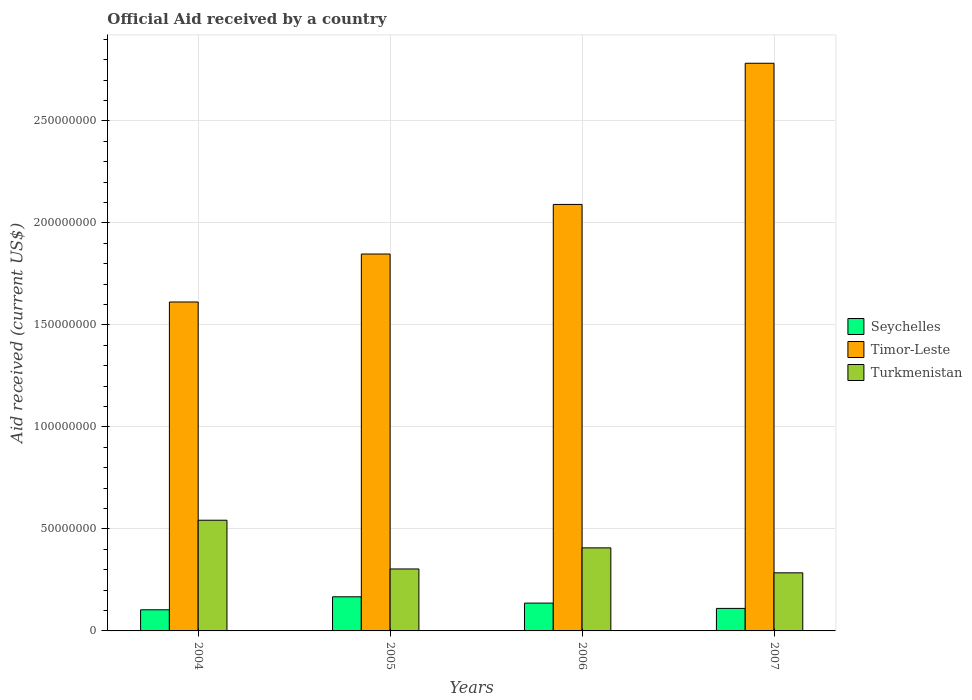How many groups of bars are there?
Ensure brevity in your answer.  4. Are the number of bars on each tick of the X-axis equal?
Your answer should be very brief. Yes. How many bars are there on the 1st tick from the left?
Your answer should be very brief. 3. What is the label of the 1st group of bars from the left?
Your answer should be very brief. 2004. What is the net official aid received in Turkmenistan in 2007?
Provide a short and direct response. 2.85e+07. Across all years, what is the maximum net official aid received in Turkmenistan?
Offer a terse response. 5.43e+07. Across all years, what is the minimum net official aid received in Seychelles?
Ensure brevity in your answer.  1.04e+07. What is the total net official aid received in Seychelles in the graph?
Ensure brevity in your answer.  5.18e+07. What is the difference between the net official aid received in Timor-Leste in 2005 and that in 2007?
Your response must be concise. -9.35e+07. What is the difference between the net official aid received in Timor-Leste in 2007 and the net official aid received in Turkmenistan in 2006?
Give a very brief answer. 2.38e+08. What is the average net official aid received in Timor-Leste per year?
Ensure brevity in your answer.  2.08e+08. In the year 2004, what is the difference between the net official aid received in Turkmenistan and net official aid received in Timor-Leste?
Your answer should be compact. -1.07e+08. In how many years, is the net official aid received in Seychelles greater than 160000000 US$?
Your answer should be very brief. 0. What is the ratio of the net official aid received in Timor-Leste in 2004 to that in 2007?
Offer a terse response. 0.58. Is the net official aid received in Timor-Leste in 2005 less than that in 2006?
Offer a very short reply. Yes. Is the difference between the net official aid received in Turkmenistan in 2005 and 2007 greater than the difference between the net official aid received in Timor-Leste in 2005 and 2007?
Ensure brevity in your answer.  Yes. What is the difference between the highest and the second highest net official aid received in Seychelles?
Make the answer very short. 3.09e+06. What is the difference between the highest and the lowest net official aid received in Seychelles?
Offer a terse response. 6.37e+06. In how many years, is the net official aid received in Turkmenistan greater than the average net official aid received in Turkmenistan taken over all years?
Your answer should be compact. 2. Is the sum of the net official aid received in Timor-Leste in 2006 and 2007 greater than the maximum net official aid received in Turkmenistan across all years?
Give a very brief answer. Yes. What does the 1st bar from the left in 2007 represents?
Offer a very short reply. Seychelles. What does the 1st bar from the right in 2006 represents?
Give a very brief answer. Turkmenistan. Are all the bars in the graph horizontal?
Your response must be concise. No. How many years are there in the graph?
Offer a terse response. 4. What is the difference between two consecutive major ticks on the Y-axis?
Ensure brevity in your answer.  5.00e+07. Are the values on the major ticks of Y-axis written in scientific E-notation?
Your answer should be compact. No. How many legend labels are there?
Give a very brief answer. 3. How are the legend labels stacked?
Give a very brief answer. Vertical. What is the title of the graph?
Your answer should be very brief. Official Aid received by a country. What is the label or title of the Y-axis?
Provide a succinct answer. Aid received (current US$). What is the Aid received (current US$) in Seychelles in 2004?
Your answer should be very brief. 1.04e+07. What is the Aid received (current US$) in Timor-Leste in 2004?
Provide a succinct answer. 1.61e+08. What is the Aid received (current US$) in Turkmenistan in 2004?
Provide a succinct answer. 5.43e+07. What is the Aid received (current US$) of Seychelles in 2005?
Provide a short and direct response. 1.67e+07. What is the Aid received (current US$) in Timor-Leste in 2005?
Your answer should be very brief. 1.85e+08. What is the Aid received (current US$) of Turkmenistan in 2005?
Offer a very short reply. 3.04e+07. What is the Aid received (current US$) of Seychelles in 2006?
Provide a succinct answer. 1.36e+07. What is the Aid received (current US$) of Timor-Leste in 2006?
Your answer should be compact. 2.09e+08. What is the Aid received (current US$) of Turkmenistan in 2006?
Offer a very short reply. 4.07e+07. What is the Aid received (current US$) of Seychelles in 2007?
Offer a very short reply. 1.10e+07. What is the Aid received (current US$) of Timor-Leste in 2007?
Offer a terse response. 2.78e+08. What is the Aid received (current US$) of Turkmenistan in 2007?
Provide a short and direct response. 2.85e+07. Across all years, what is the maximum Aid received (current US$) in Seychelles?
Offer a terse response. 1.67e+07. Across all years, what is the maximum Aid received (current US$) in Timor-Leste?
Provide a short and direct response. 2.78e+08. Across all years, what is the maximum Aid received (current US$) in Turkmenistan?
Offer a terse response. 5.43e+07. Across all years, what is the minimum Aid received (current US$) in Seychelles?
Your answer should be compact. 1.04e+07. Across all years, what is the minimum Aid received (current US$) of Timor-Leste?
Your answer should be very brief. 1.61e+08. Across all years, what is the minimum Aid received (current US$) in Turkmenistan?
Your answer should be compact. 2.85e+07. What is the total Aid received (current US$) of Seychelles in the graph?
Ensure brevity in your answer.  5.18e+07. What is the total Aid received (current US$) of Timor-Leste in the graph?
Give a very brief answer. 8.33e+08. What is the total Aid received (current US$) in Turkmenistan in the graph?
Your response must be concise. 1.54e+08. What is the difference between the Aid received (current US$) of Seychelles in 2004 and that in 2005?
Your response must be concise. -6.37e+06. What is the difference between the Aid received (current US$) of Timor-Leste in 2004 and that in 2005?
Keep it short and to the point. -2.35e+07. What is the difference between the Aid received (current US$) of Turkmenistan in 2004 and that in 2005?
Ensure brevity in your answer.  2.39e+07. What is the difference between the Aid received (current US$) of Seychelles in 2004 and that in 2006?
Make the answer very short. -3.28e+06. What is the difference between the Aid received (current US$) of Timor-Leste in 2004 and that in 2006?
Your answer should be very brief. -4.78e+07. What is the difference between the Aid received (current US$) of Turkmenistan in 2004 and that in 2006?
Make the answer very short. 1.36e+07. What is the difference between the Aid received (current US$) of Seychelles in 2004 and that in 2007?
Give a very brief answer. -6.80e+05. What is the difference between the Aid received (current US$) of Timor-Leste in 2004 and that in 2007?
Keep it short and to the point. -1.17e+08. What is the difference between the Aid received (current US$) in Turkmenistan in 2004 and that in 2007?
Your answer should be compact. 2.58e+07. What is the difference between the Aid received (current US$) in Seychelles in 2005 and that in 2006?
Give a very brief answer. 3.09e+06. What is the difference between the Aid received (current US$) of Timor-Leste in 2005 and that in 2006?
Provide a short and direct response. -2.43e+07. What is the difference between the Aid received (current US$) of Turkmenistan in 2005 and that in 2006?
Your response must be concise. -1.03e+07. What is the difference between the Aid received (current US$) in Seychelles in 2005 and that in 2007?
Offer a very short reply. 5.69e+06. What is the difference between the Aid received (current US$) in Timor-Leste in 2005 and that in 2007?
Make the answer very short. -9.35e+07. What is the difference between the Aid received (current US$) of Turkmenistan in 2005 and that in 2007?
Your answer should be very brief. 1.89e+06. What is the difference between the Aid received (current US$) of Seychelles in 2006 and that in 2007?
Provide a short and direct response. 2.60e+06. What is the difference between the Aid received (current US$) in Timor-Leste in 2006 and that in 2007?
Your answer should be compact. -6.92e+07. What is the difference between the Aid received (current US$) of Turkmenistan in 2006 and that in 2007?
Your response must be concise. 1.22e+07. What is the difference between the Aid received (current US$) of Seychelles in 2004 and the Aid received (current US$) of Timor-Leste in 2005?
Keep it short and to the point. -1.74e+08. What is the difference between the Aid received (current US$) in Seychelles in 2004 and the Aid received (current US$) in Turkmenistan in 2005?
Provide a succinct answer. -2.00e+07. What is the difference between the Aid received (current US$) in Timor-Leste in 2004 and the Aid received (current US$) in Turkmenistan in 2005?
Your answer should be compact. 1.31e+08. What is the difference between the Aid received (current US$) in Seychelles in 2004 and the Aid received (current US$) in Timor-Leste in 2006?
Your answer should be very brief. -1.99e+08. What is the difference between the Aid received (current US$) in Seychelles in 2004 and the Aid received (current US$) in Turkmenistan in 2006?
Offer a terse response. -3.04e+07. What is the difference between the Aid received (current US$) of Timor-Leste in 2004 and the Aid received (current US$) of Turkmenistan in 2006?
Your answer should be compact. 1.21e+08. What is the difference between the Aid received (current US$) of Seychelles in 2004 and the Aid received (current US$) of Timor-Leste in 2007?
Your response must be concise. -2.68e+08. What is the difference between the Aid received (current US$) of Seychelles in 2004 and the Aid received (current US$) of Turkmenistan in 2007?
Offer a very short reply. -1.81e+07. What is the difference between the Aid received (current US$) in Timor-Leste in 2004 and the Aid received (current US$) in Turkmenistan in 2007?
Give a very brief answer. 1.33e+08. What is the difference between the Aid received (current US$) in Seychelles in 2005 and the Aid received (current US$) in Timor-Leste in 2006?
Make the answer very short. -1.92e+08. What is the difference between the Aid received (current US$) in Seychelles in 2005 and the Aid received (current US$) in Turkmenistan in 2006?
Make the answer very short. -2.40e+07. What is the difference between the Aid received (current US$) of Timor-Leste in 2005 and the Aid received (current US$) of Turkmenistan in 2006?
Your response must be concise. 1.44e+08. What is the difference between the Aid received (current US$) in Seychelles in 2005 and the Aid received (current US$) in Timor-Leste in 2007?
Provide a succinct answer. -2.62e+08. What is the difference between the Aid received (current US$) in Seychelles in 2005 and the Aid received (current US$) in Turkmenistan in 2007?
Offer a very short reply. -1.18e+07. What is the difference between the Aid received (current US$) in Timor-Leste in 2005 and the Aid received (current US$) in Turkmenistan in 2007?
Ensure brevity in your answer.  1.56e+08. What is the difference between the Aid received (current US$) of Seychelles in 2006 and the Aid received (current US$) of Timor-Leste in 2007?
Your answer should be very brief. -2.65e+08. What is the difference between the Aid received (current US$) of Seychelles in 2006 and the Aid received (current US$) of Turkmenistan in 2007?
Your response must be concise. -1.48e+07. What is the difference between the Aid received (current US$) in Timor-Leste in 2006 and the Aid received (current US$) in Turkmenistan in 2007?
Provide a succinct answer. 1.81e+08. What is the average Aid received (current US$) in Seychelles per year?
Your answer should be very brief. 1.29e+07. What is the average Aid received (current US$) in Timor-Leste per year?
Your response must be concise. 2.08e+08. What is the average Aid received (current US$) in Turkmenistan per year?
Offer a very short reply. 3.85e+07. In the year 2004, what is the difference between the Aid received (current US$) of Seychelles and Aid received (current US$) of Timor-Leste?
Offer a very short reply. -1.51e+08. In the year 2004, what is the difference between the Aid received (current US$) of Seychelles and Aid received (current US$) of Turkmenistan?
Your response must be concise. -4.39e+07. In the year 2004, what is the difference between the Aid received (current US$) in Timor-Leste and Aid received (current US$) in Turkmenistan?
Keep it short and to the point. 1.07e+08. In the year 2005, what is the difference between the Aid received (current US$) of Seychelles and Aid received (current US$) of Timor-Leste?
Ensure brevity in your answer.  -1.68e+08. In the year 2005, what is the difference between the Aid received (current US$) of Seychelles and Aid received (current US$) of Turkmenistan?
Your answer should be very brief. -1.36e+07. In the year 2005, what is the difference between the Aid received (current US$) in Timor-Leste and Aid received (current US$) in Turkmenistan?
Give a very brief answer. 1.54e+08. In the year 2006, what is the difference between the Aid received (current US$) in Seychelles and Aid received (current US$) in Timor-Leste?
Your answer should be very brief. -1.95e+08. In the year 2006, what is the difference between the Aid received (current US$) of Seychelles and Aid received (current US$) of Turkmenistan?
Provide a succinct answer. -2.71e+07. In the year 2006, what is the difference between the Aid received (current US$) in Timor-Leste and Aid received (current US$) in Turkmenistan?
Offer a very short reply. 1.68e+08. In the year 2007, what is the difference between the Aid received (current US$) of Seychelles and Aid received (current US$) of Timor-Leste?
Your answer should be very brief. -2.67e+08. In the year 2007, what is the difference between the Aid received (current US$) in Seychelles and Aid received (current US$) in Turkmenistan?
Your response must be concise. -1.74e+07. In the year 2007, what is the difference between the Aid received (current US$) of Timor-Leste and Aid received (current US$) of Turkmenistan?
Your response must be concise. 2.50e+08. What is the ratio of the Aid received (current US$) of Seychelles in 2004 to that in 2005?
Offer a terse response. 0.62. What is the ratio of the Aid received (current US$) of Timor-Leste in 2004 to that in 2005?
Offer a very short reply. 0.87. What is the ratio of the Aid received (current US$) in Turkmenistan in 2004 to that in 2005?
Offer a terse response. 1.79. What is the ratio of the Aid received (current US$) of Seychelles in 2004 to that in 2006?
Give a very brief answer. 0.76. What is the ratio of the Aid received (current US$) in Timor-Leste in 2004 to that in 2006?
Ensure brevity in your answer.  0.77. What is the ratio of the Aid received (current US$) of Turkmenistan in 2004 to that in 2006?
Keep it short and to the point. 1.33. What is the ratio of the Aid received (current US$) of Seychelles in 2004 to that in 2007?
Provide a short and direct response. 0.94. What is the ratio of the Aid received (current US$) of Timor-Leste in 2004 to that in 2007?
Provide a short and direct response. 0.58. What is the ratio of the Aid received (current US$) in Turkmenistan in 2004 to that in 2007?
Provide a succinct answer. 1.91. What is the ratio of the Aid received (current US$) of Seychelles in 2005 to that in 2006?
Give a very brief answer. 1.23. What is the ratio of the Aid received (current US$) of Timor-Leste in 2005 to that in 2006?
Your answer should be compact. 0.88. What is the ratio of the Aid received (current US$) of Turkmenistan in 2005 to that in 2006?
Offer a terse response. 0.75. What is the ratio of the Aid received (current US$) of Seychelles in 2005 to that in 2007?
Make the answer very short. 1.52. What is the ratio of the Aid received (current US$) in Timor-Leste in 2005 to that in 2007?
Provide a short and direct response. 0.66. What is the ratio of the Aid received (current US$) of Turkmenistan in 2005 to that in 2007?
Your answer should be very brief. 1.07. What is the ratio of the Aid received (current US$) in Seychelles in 2006 to that in 2007?
Offer a very short reply. 1.24. What is the ratio of the Aid received (current US$) in Timor-Leste in 2006 to that in 2007?
Your answer should be very brief. 0.75. What is the ratio of the Aid received (current US$) in Turkmenistan in 2006 to that in 2007?
Keep it short and to the point. 1.43. What is the difference between the highest and the second highest Aid received (current US$) of Seychelles?
Your answer should be compact. 3.09e+06. What is the difference between the highest and the second highest Aid received (current US$) in Timor-Leste?
Provide a succinct answer. 6.92e+07. What is the difference between the highest and the second highest Aid received (current US$) in Turkmenistan?
Offer a terse response. 1.36e+07. What is the difference between the highest and the lowest Aid received (current US$) in Seychelles?
Your response must be concise. 6.37e+06. What is the difference between the highest and the lowest Aid received (current US$) in Timor-Leste?
Make the answer very short. 1.17e+08. What is the difference between the highest and the lowest Aid received (current US$) of Turkmenistan?
Make the answer very short. 2.58e+07. 